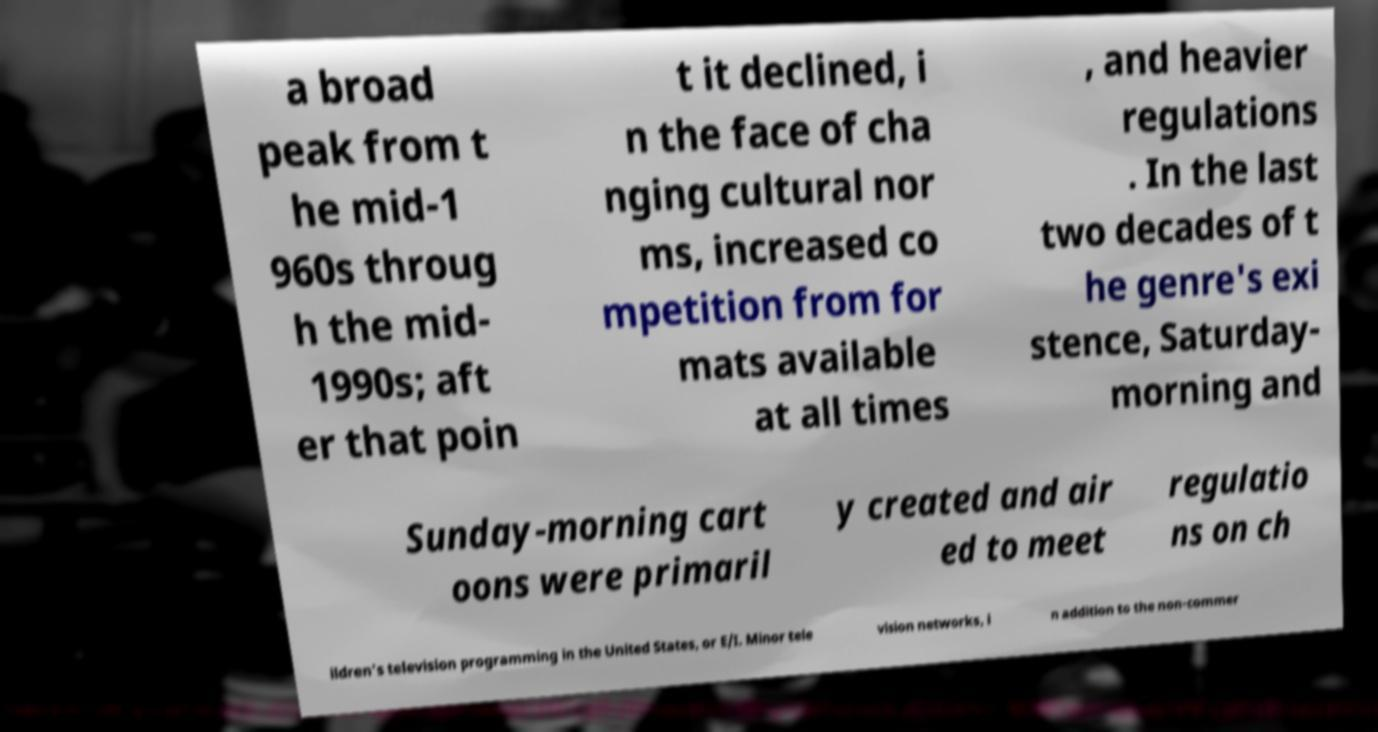There's text embedded in this image that I need extracted. Can you transcribe it verbatim? a broad peak from t he mid-1 960s throug h the mid- 1990s; aft er that poin t it declined, i n the face of cha nging cultural nor ms, increased co mpetition from for mats available at all times , and heavier regulations . In the last two decades of t he genre's exi stence, Saturday- morning and Sunday-morning cart oons were primaril y created and air ed to meet regulatio ns on ch ildren's television programming in the United States, or E/I. Minor tele vision networks, i n addition to the non-commer 